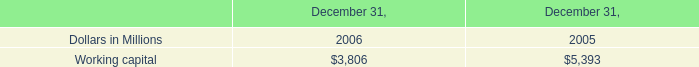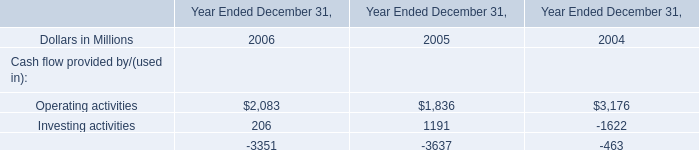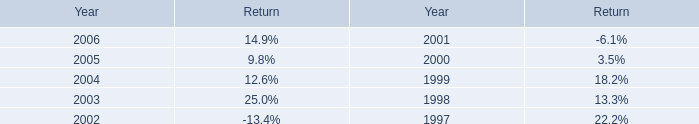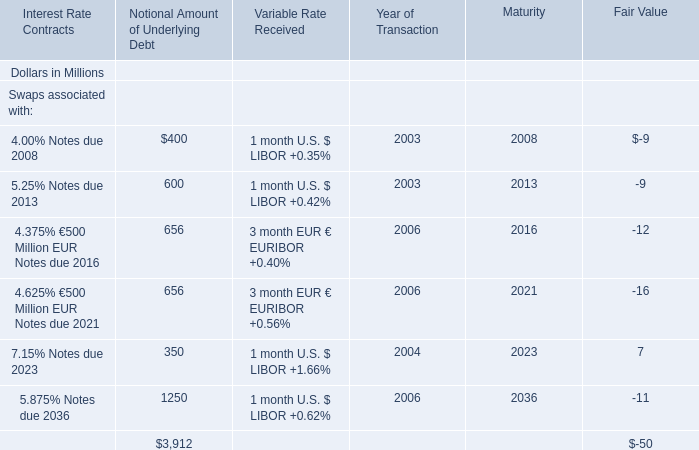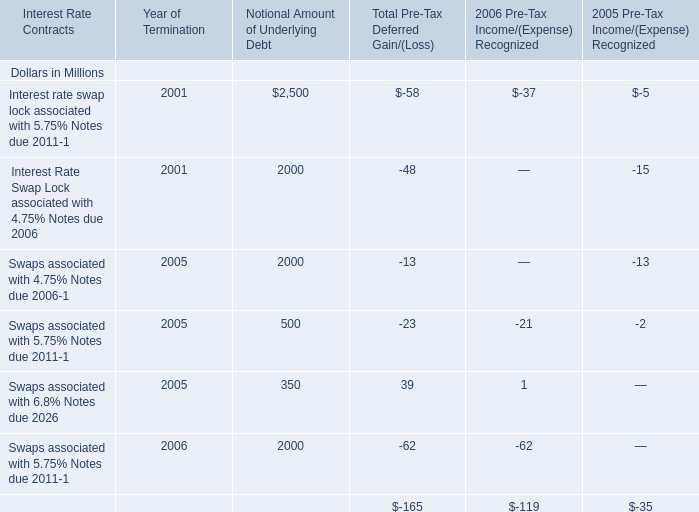What's the sum of Operating activities of Year Ended December 31, 2004, and Working capital of December 31, 2005 ? 
Computations: (3176.0 + 5393.0)
Answer: 8569.0. 